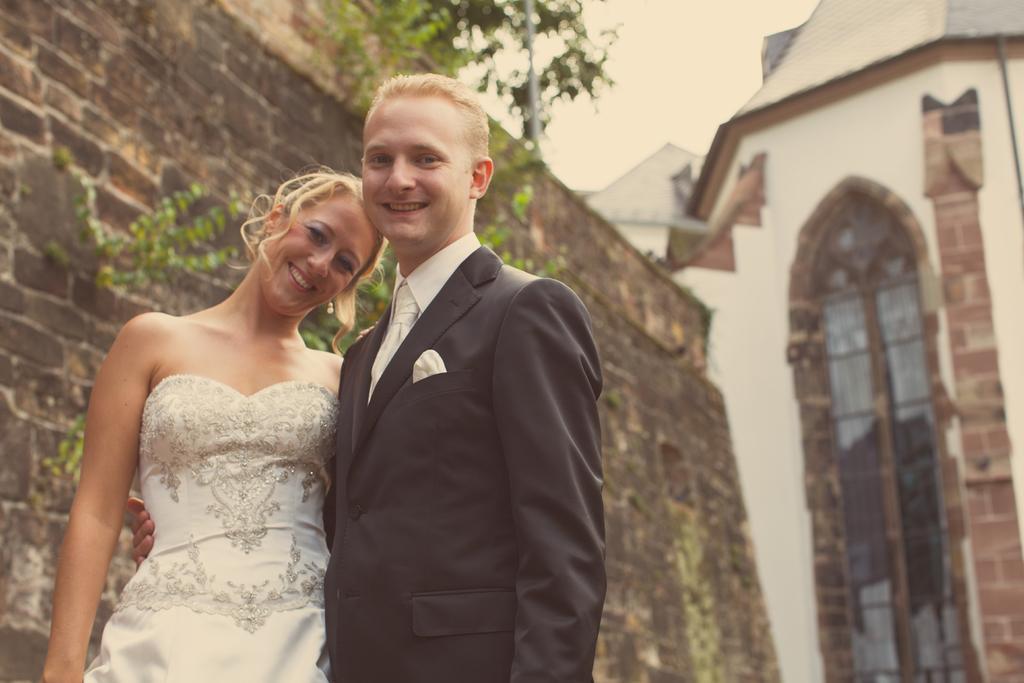Can you describe this image briefly? In the foreground of the image there are two persons standing. in the background of the image there is a building. There is wall. There are plants. At the top of the image there is sky. 